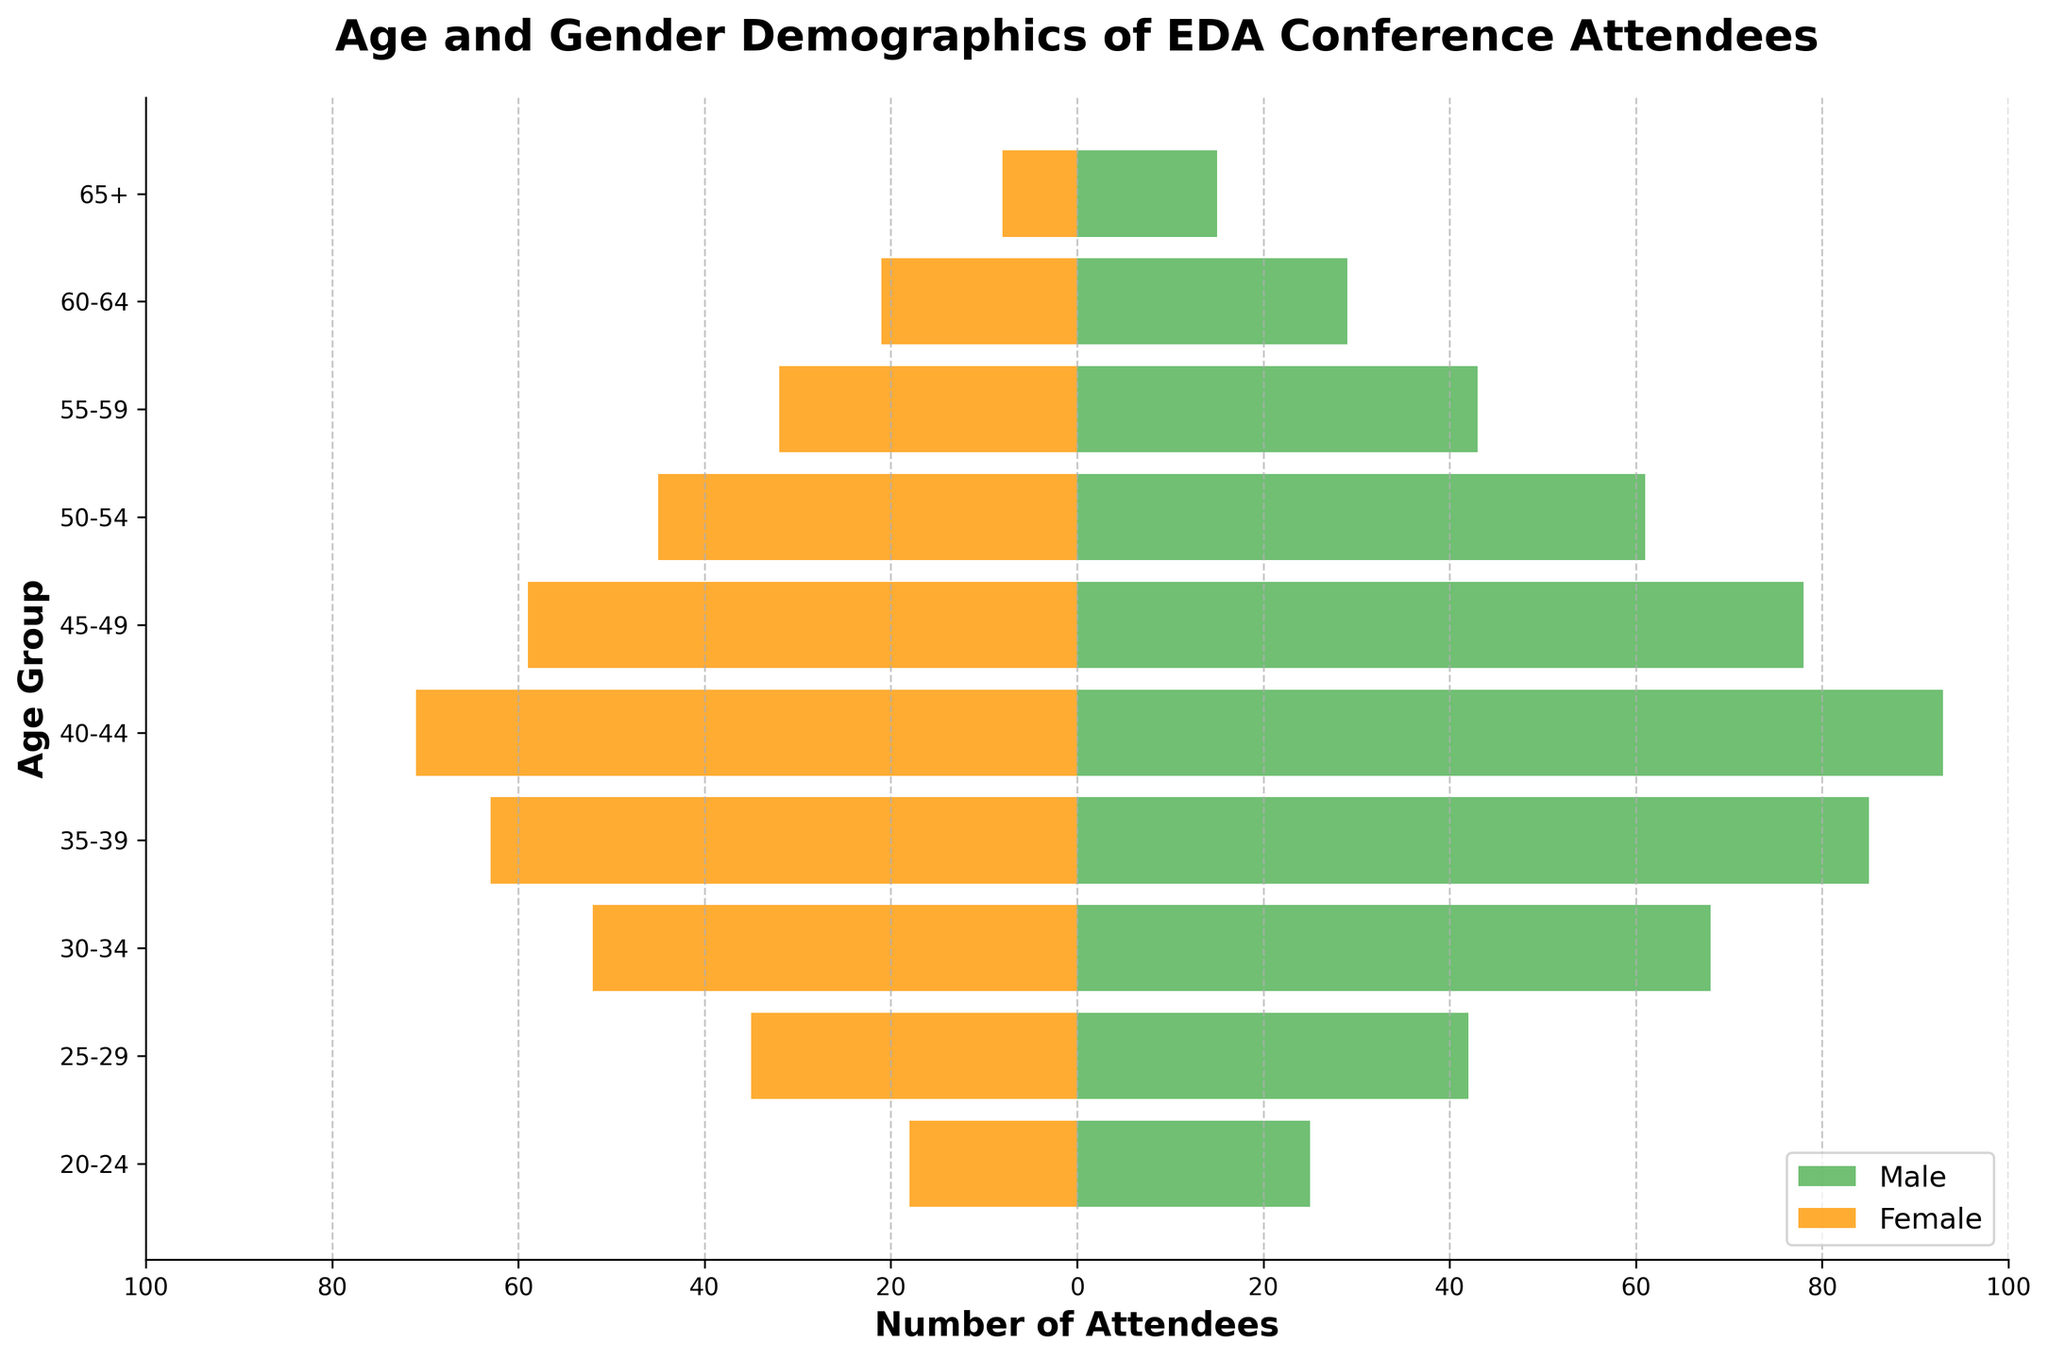What is the title of the figure? The title is usually placed at the top of the figure and is clearly labeled to describe what the figure is about. In this case, it is centered and set in a bold font.
Answer: Age and Gender Demographics of EDA Conference Attendees How many age groups are represented in the figure? Look at the y-axis, which lists the age groups. Count all distinct labels from top to bottom.
Answer: 10 Which age group has the highest number of male attendees? Locate the age group bars on the y-axis, then find the bar on the positive side of the x-axis (right side) that is the longest.
Answer: 40-44 Which age group has the least number of female attendees? Locate the age group bars on the y-axis, then find the bar on the negative side of the x-axis (left side) that is the shortest.
Answer: 65+ What is the total number of attendees in the 30-34 age group? Find the lengths of the male and female bars for the 30-34 age group and add them up. Male: 68, Female: 52. Therefore, 68 + 52 = 120.
Answer: 120 How many more male attendees are there than female attendees in the 45-49 age group? Find the lengths of the male and female bars for 45-49. Male: 78, Female: 59. Calculate the difference: 78 - 59 = 19.
Answer: 19 In which age group is the gender distribution most balanced? Compare the lengths of male and female bars across all age groups to find where they are closest. For instance, in the 25-29 age group, Male: 42, Female: 35.
Answer: 25-29 How does the number of attendees in the 60-64 age group compare to the 20-24 age group? Compare the total lengths of the male and female bars for both age groups. For 60-64: Male: 29, Female: 21; Total = 29 + 21 = 50. For 20-24: Male: 25, Female: 18; Total = 25 + 18 = 43.
Answer: 60-64 has more attendees What's the average number of female attendees across all age groups? Sum the number of female attendees in all age groups and divide by the number of age groups. (18 + 35 + 52 + 63 + 71 + 59 + 45 + 32 + 21 + 8) / 10 = 40.4.
Answer: 40.4 Is there any age group where male attendees are less than female attendees? Look for any age group where the length of the male bar is shorter than the corresponding female bar. Scanning quickly, none of the male bars are shorter.
Answer: No 